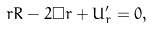<formula> <loc_0><loc_0><loc_500><loc_500>r R - 2 \Box r + U ^ { \prime } _ { r } = 0 ,</formula> 